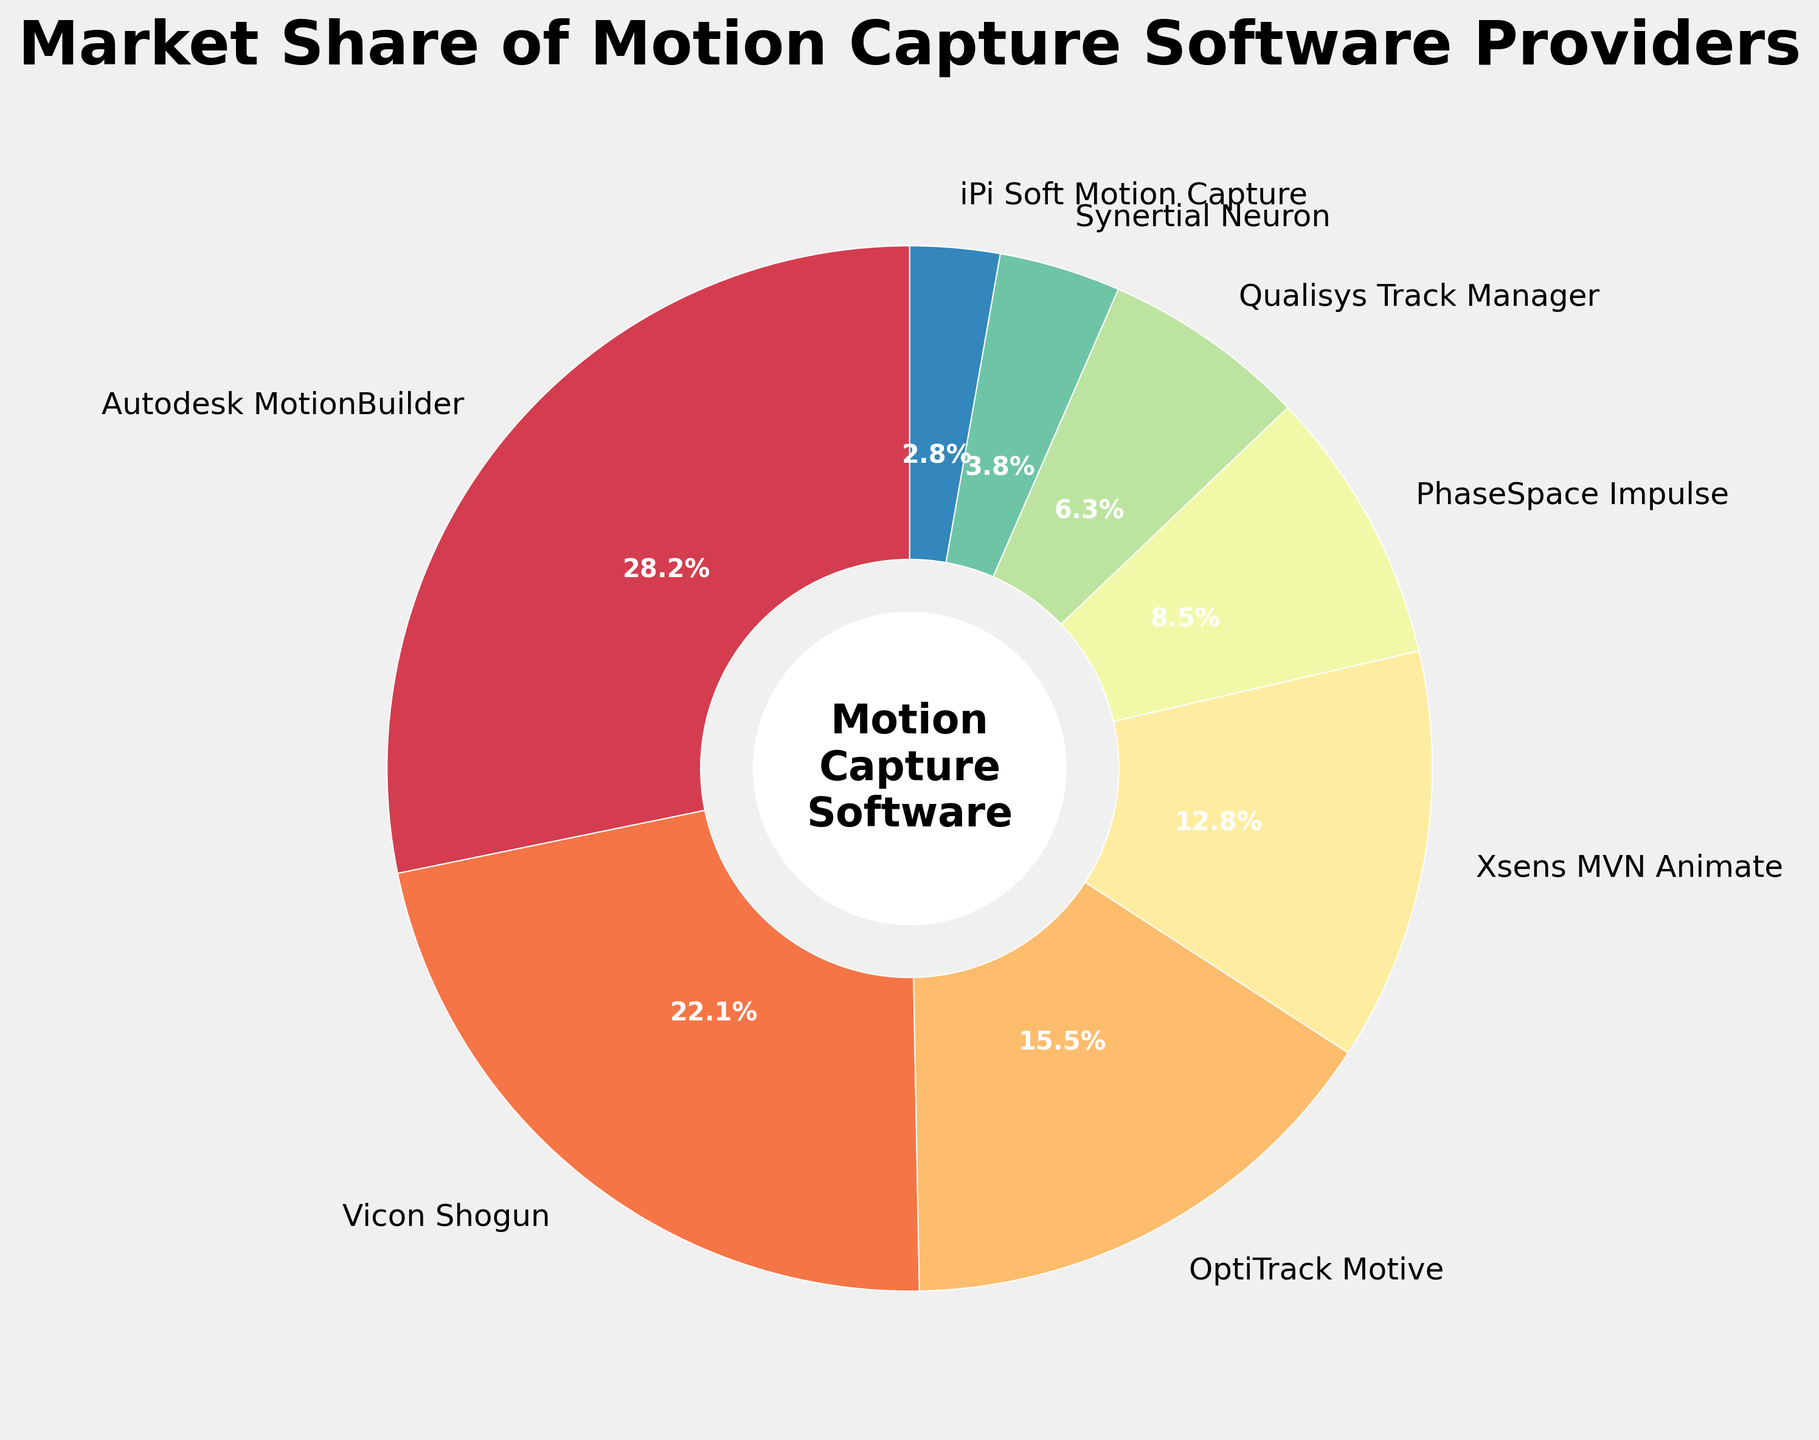What is the market share of Autodesk MotionBuilder? Looking at the pie chart, the section labeled Autodesk MotionBuilder shows a market share percentage.
Answer: 28.5% Which motion capture software has the smallest market share? Observing the pie chart, the smallest segment corresponds to iPi Soft Motion Capture.
Answer: iPi Soft Motion Capture How much more market share does Autodesk MotionBuilder have compared to Vicon Shogun? Autodesk MotionBuilder has a market share of 28.5% and Vicon Shogun has 22.3%. The difference is calculated as 28.5 - 22.3.
Answer: 6.2% What is the combined market share of OptiTrack Motive and Xsens MVN Animate? OptiTrack Motive has 15.7% and Xsens MVN Animate has 12.9%. Add these percentages together: 15.7 + 12.9.
Answer: 28.6% Which software providers have market shares greater than 10%? Observing the pie chart, the segments for Autodesk MotionBuilder (28.5%), Vicon Shogun (22.3%), OptiTrack Motive (15.7%), and Xsens MVN Animate (12.9%) are all greater than 10%.
Answer: Autodesk MotionBuilder, Vicon Shogun, OptiTrack Motive, Xsens MVN Animate How does the market share of PhaseSpace Impulse compare to Qualisys Track Manager? Comparing the pie chart segments, PhaseSpace Impulse has 8.6% and Qualisys Track Manager has 6.4%.
Answer: PhaseSpace Impulse has a higher market share Which software section is colored similarly to autumn leaves on the pie chart? Based on the color gradient used in Spectral colormap, the segment for Autodesk MotionBuilder features an autumn leaves-like color.
Answer: Autodesk MotionBuilder What is the aggregate market share of the software providers with shares less than 10%? Summing the market shares of PhaseSpace Impulse (8.6%), Qualisys Track Manager (6.4%), Synertial Neuron (3.8%), and iPi Soft Motion Capture (2.8%) results in 21.6%.
Answer: 21.6% Which segment on the pie chart has the highest market share, and what visual cues indicate this? The pie chart segment for Autodesk MotionBuilder is the largest, indicated by its widest wedge.
Answer: Autodesk MotionBuilder, widest wedge 